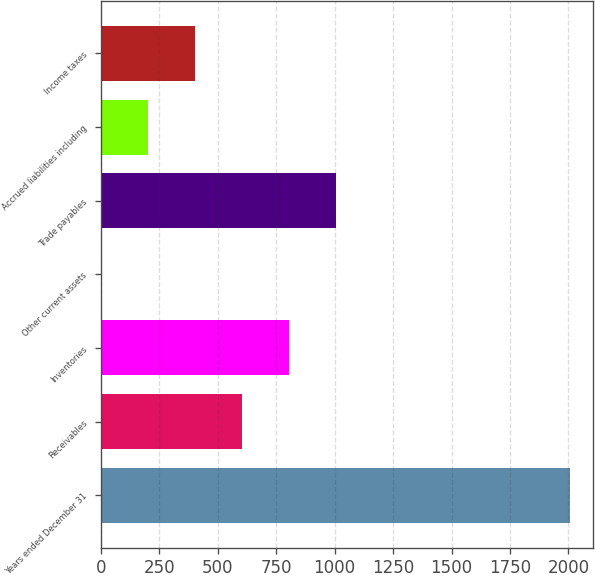Convert chart. <chart><loc_0><loc_0><loc_500><loc_500><bar_chart><fcel>Years ended December 31<fcel>Receivables<fcel>Inventories<fcel>Other current assets<fcel>Trade payables<fcel>Accrued liabilities including<fcel>Income taxes<nl><fcel>2006<fcel>602.85<fcel>803.3<fcel>1.5<fcel>1003.75<fcel>201.95<fcel>402.4<nl></chart> 